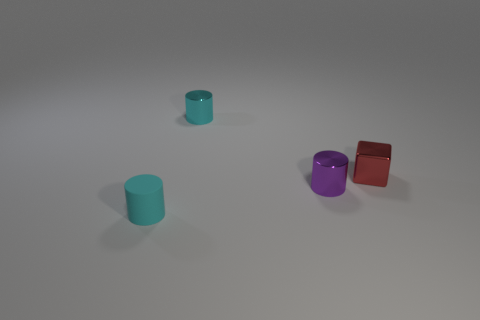Subtract all cyan cylinders. How many cylinders are left? 1 Subtract 1 cylinders. How many cylinders are left? 2 Add 1 small red shiny cubes. How many objects exist? 5 Subtract all cubes. How many objects are left? 3 Subtract all small matte cylinders. Subtract all large green metallic cylinders. How many objects are left? 3 Add 4 small red blocks. How many small red blocks are left? 5 Add 4 tiny red metallic blocks. How many tiny red metallic blocks exist? 5 Subtract 0 red spheres. How many objects are left? 4 